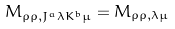Convert formula to latex. <formula><loc_0><loc_0><loc_500><loc_500>M _ { \rho \rho , J ^ { a } \lambda K ^ { b } \mu } = M _ { \rho \rho , \lambda \mu }</formula> 